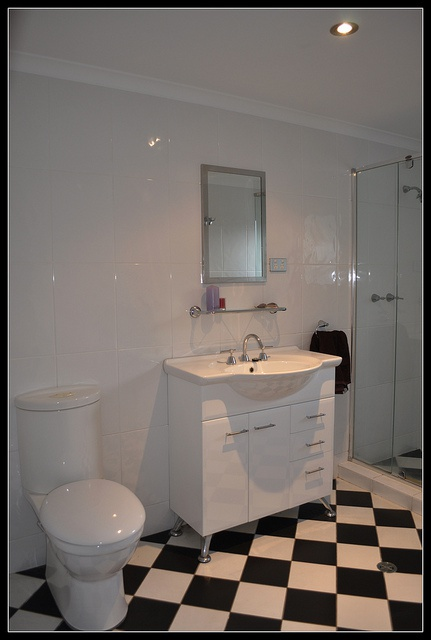Describe the objects in this image and their specific colors. I can see toilet in black and gray tones, sink in black, gray, and tan tones, and sink in black, tan, and gray tones in this image. 